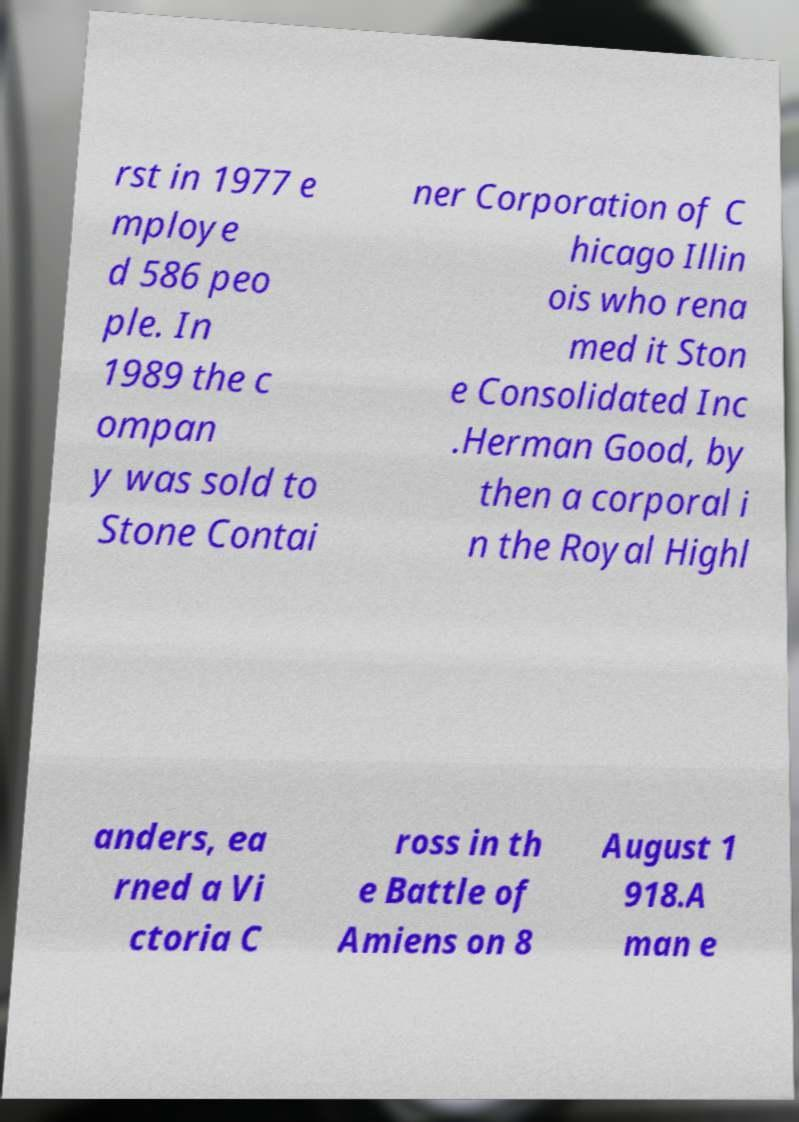There's text embedded in this image that I need extracted. Can you transcribe it verbatim? rst in 1977 e mploye d 586 peo ple. In 1989 the c ompan y was sold to Stone Contai ner Corporation of C hicago Illin ois who rena med it Ston e Consolidated Inc .Herman Good, by then a corporal i n the Royal Highl anders, ea rned a Vi ctoria C ross in th e Battle of Amiens on 8 August 1 918.A man e 